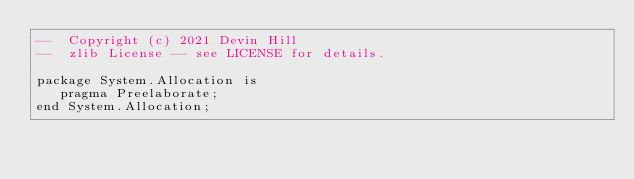<code> <loc_0><loc_0><loc_500><loc_500><_Ada_>--  Copyright (c) 2021 Devin Hill
--  zlib License -- see LICENSE for details.

package System.Allocation is
   pragma Preelaborate;
end System.Allocation;</code> 